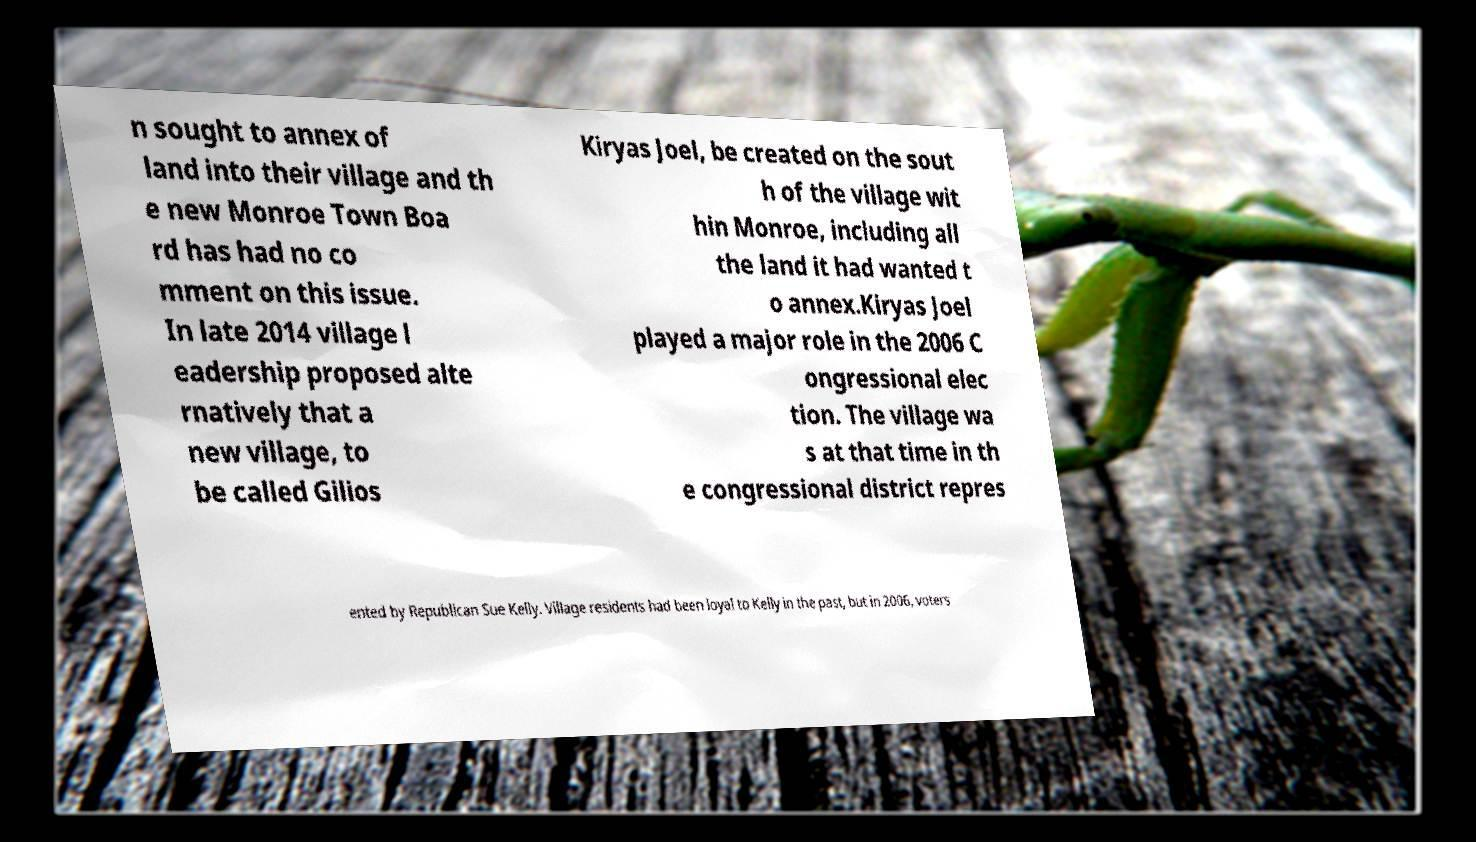I need the written content from this picture converted into text. Can you do that? n sought to annex of land into their village and th e new Monroe Town Boa rd has had no co mment on this issue. In late 2014 village l eadership proposed alte rnatively that a new village, to be called Gilios Kiryas Joel, be created on the sout h of the village wit hin Monroe, including all the land it had wanted t o annex.Kiryas Joel played a major role in the 2006 C ongressional elec tion. The village wa s at that time in th e congressional district repres ented by Republican Sue Kelly. Village residents had been loyal to Kelly in the past, but in 2006, voters 